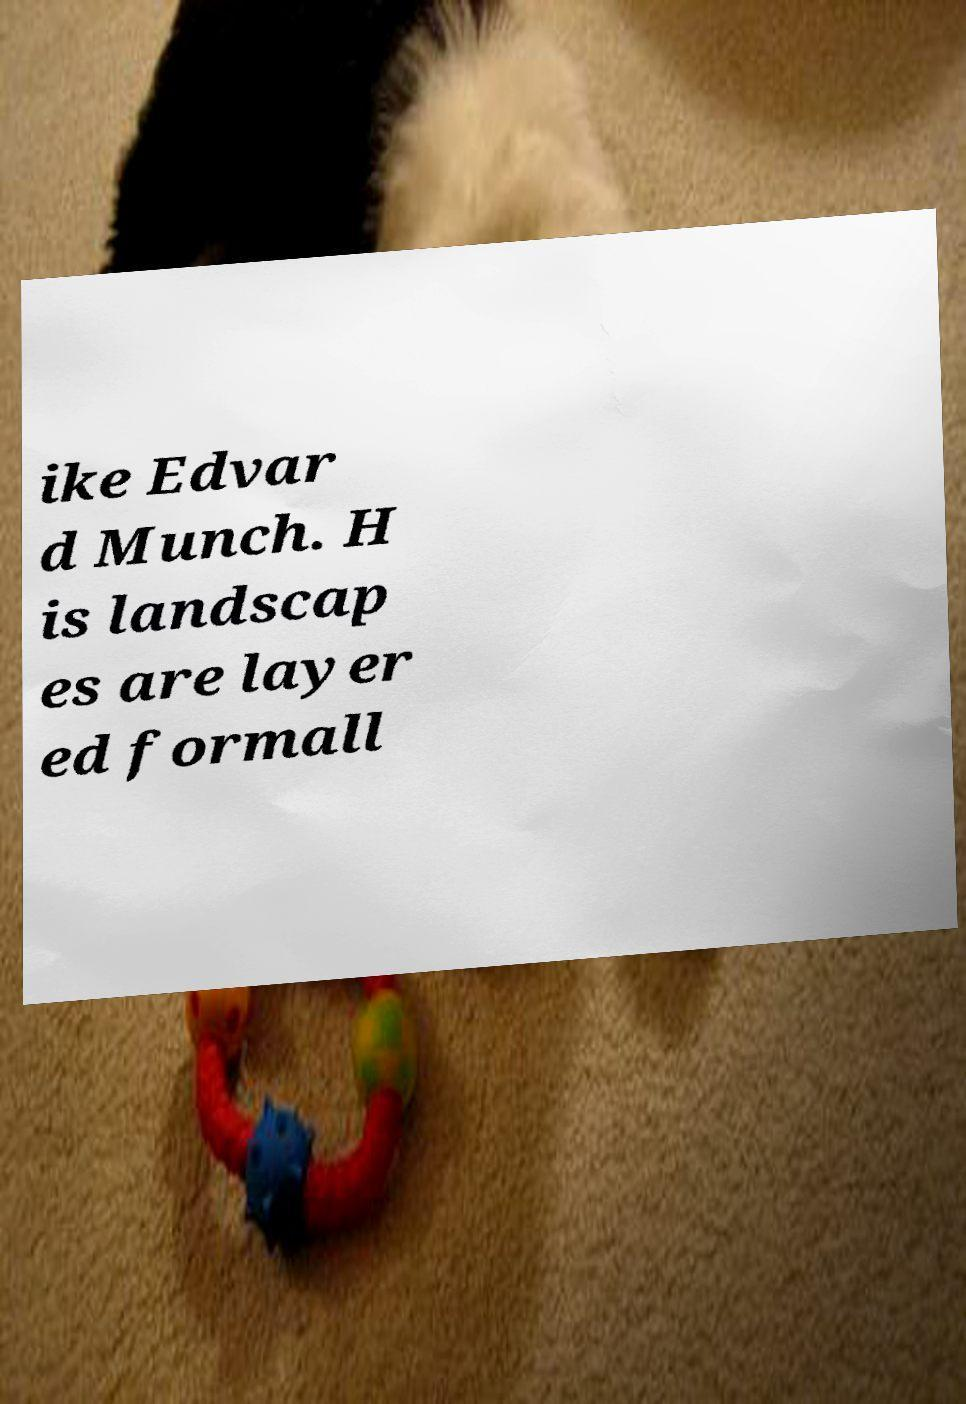Can you read and provide the text displayed in the image?This photo seems to have some interesting text. Can you extract and type it out for me? ike Edvar d Munch. H is landscap es are layer ed formall 